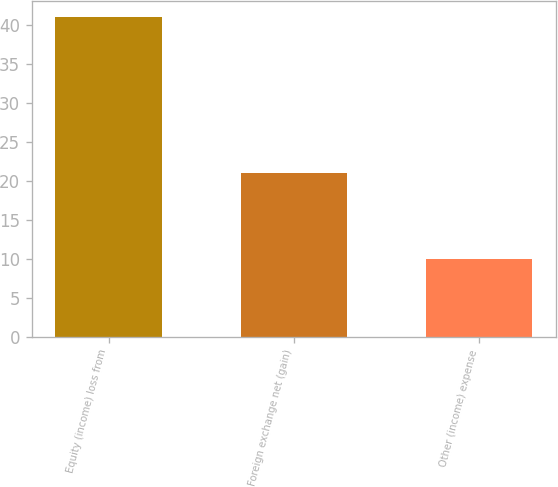Convert chart to OTSL. <chart><loc_0><loc_0><loc_500><loc_500><bar_chart><fcel>Equity (income) loss from<fcel>Foreign exchange net (gain)<fcel>Other (income) expense<nl><fcel>41<fcel>21<fcel>10<nl></chart> 